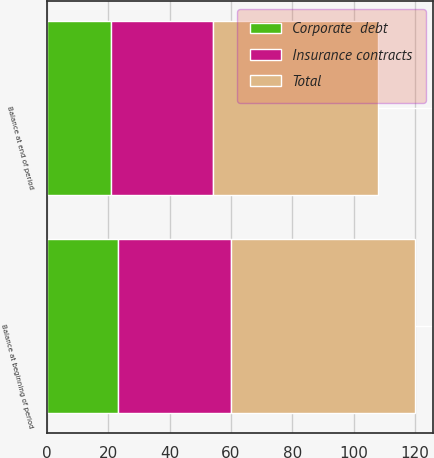<chart> <loc_0><loc_0><loc_500><loc_500><stacked_bar_chart><ecel><fcel>Balance at beginning of period<fcel>Balance at end of period<nl><fcel>Corporate  debt<fcel>23<fcel>21<nl><fcel>Insurance contracts<fcel>37<fcel>33<nl><fcel>Total<fcel>60<fcel>54<nl></chart> 